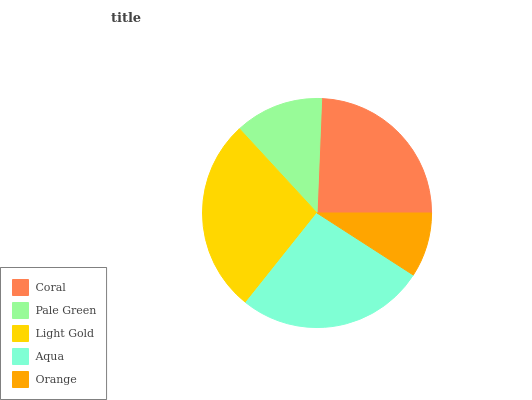Is Orange the minimum?
Answer yes or no. Yes. Is Light Gold the maximum?
Answer yes or no. Yes. Is Pale Green the minimum?
Answer yes or no. No. Is Pale Green the maximum?
Answer yes or no. No. Is Coral greater than Pale Green?
Answer yes or no. Yes. Is Pale Green less than Coral?
Answer yes or no. Yes. Is Pale Green greater than Coral?
Answer yes or no. No. Is Coral less than Pale Green?
Answer yes or no. No. Is Coral the high median?
Answer yes or no. Yes. Is Coral the low median?
Answer yes or no. Yes. Is Light Gold the high median?
Answer yes or no. No. Is Pale Green the low median?
Answer yes or no. No. 